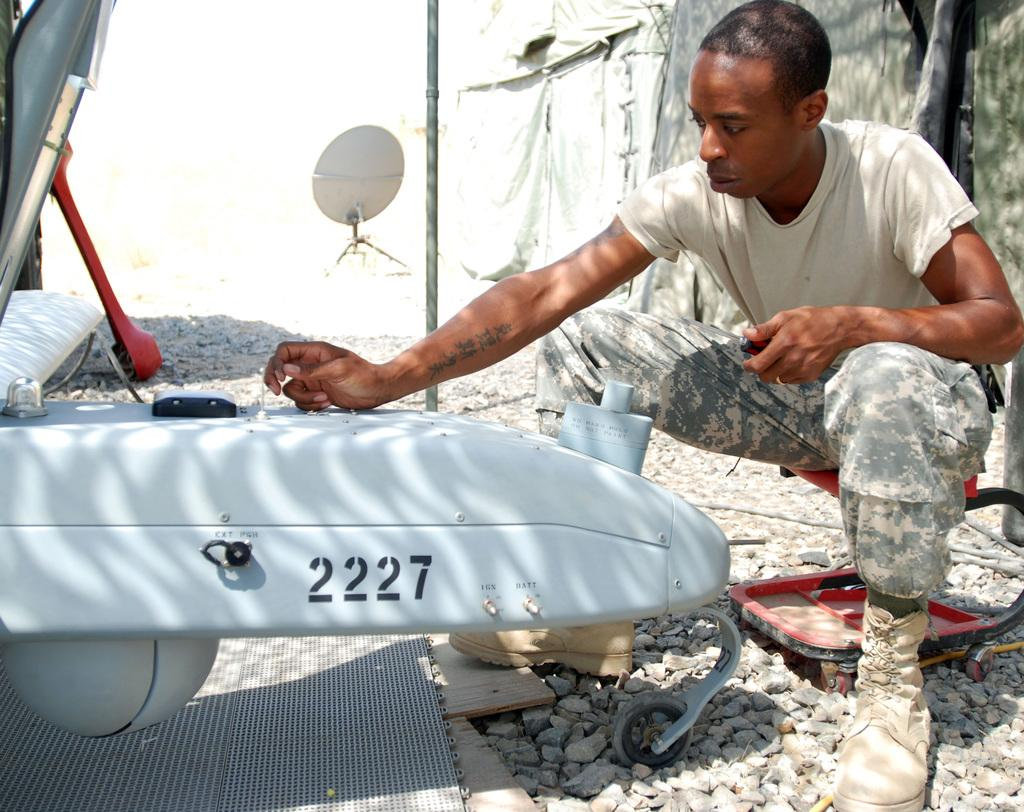What is the person in the image doing? The person is sitting in the image. What is the person wearing? The person is wearing a white shirt. What can be seen in the sky in the image? There is an aircraft in the image. What color is the aircraft? The aircraft is white in color. What is visible in the background of the image? There is a pole and stones in the background of the image. What type of bread is being used as a sail for the aircraft in the image? There is no bread or sail present in the image; the aircraft is white and does not have any bread-like features. 